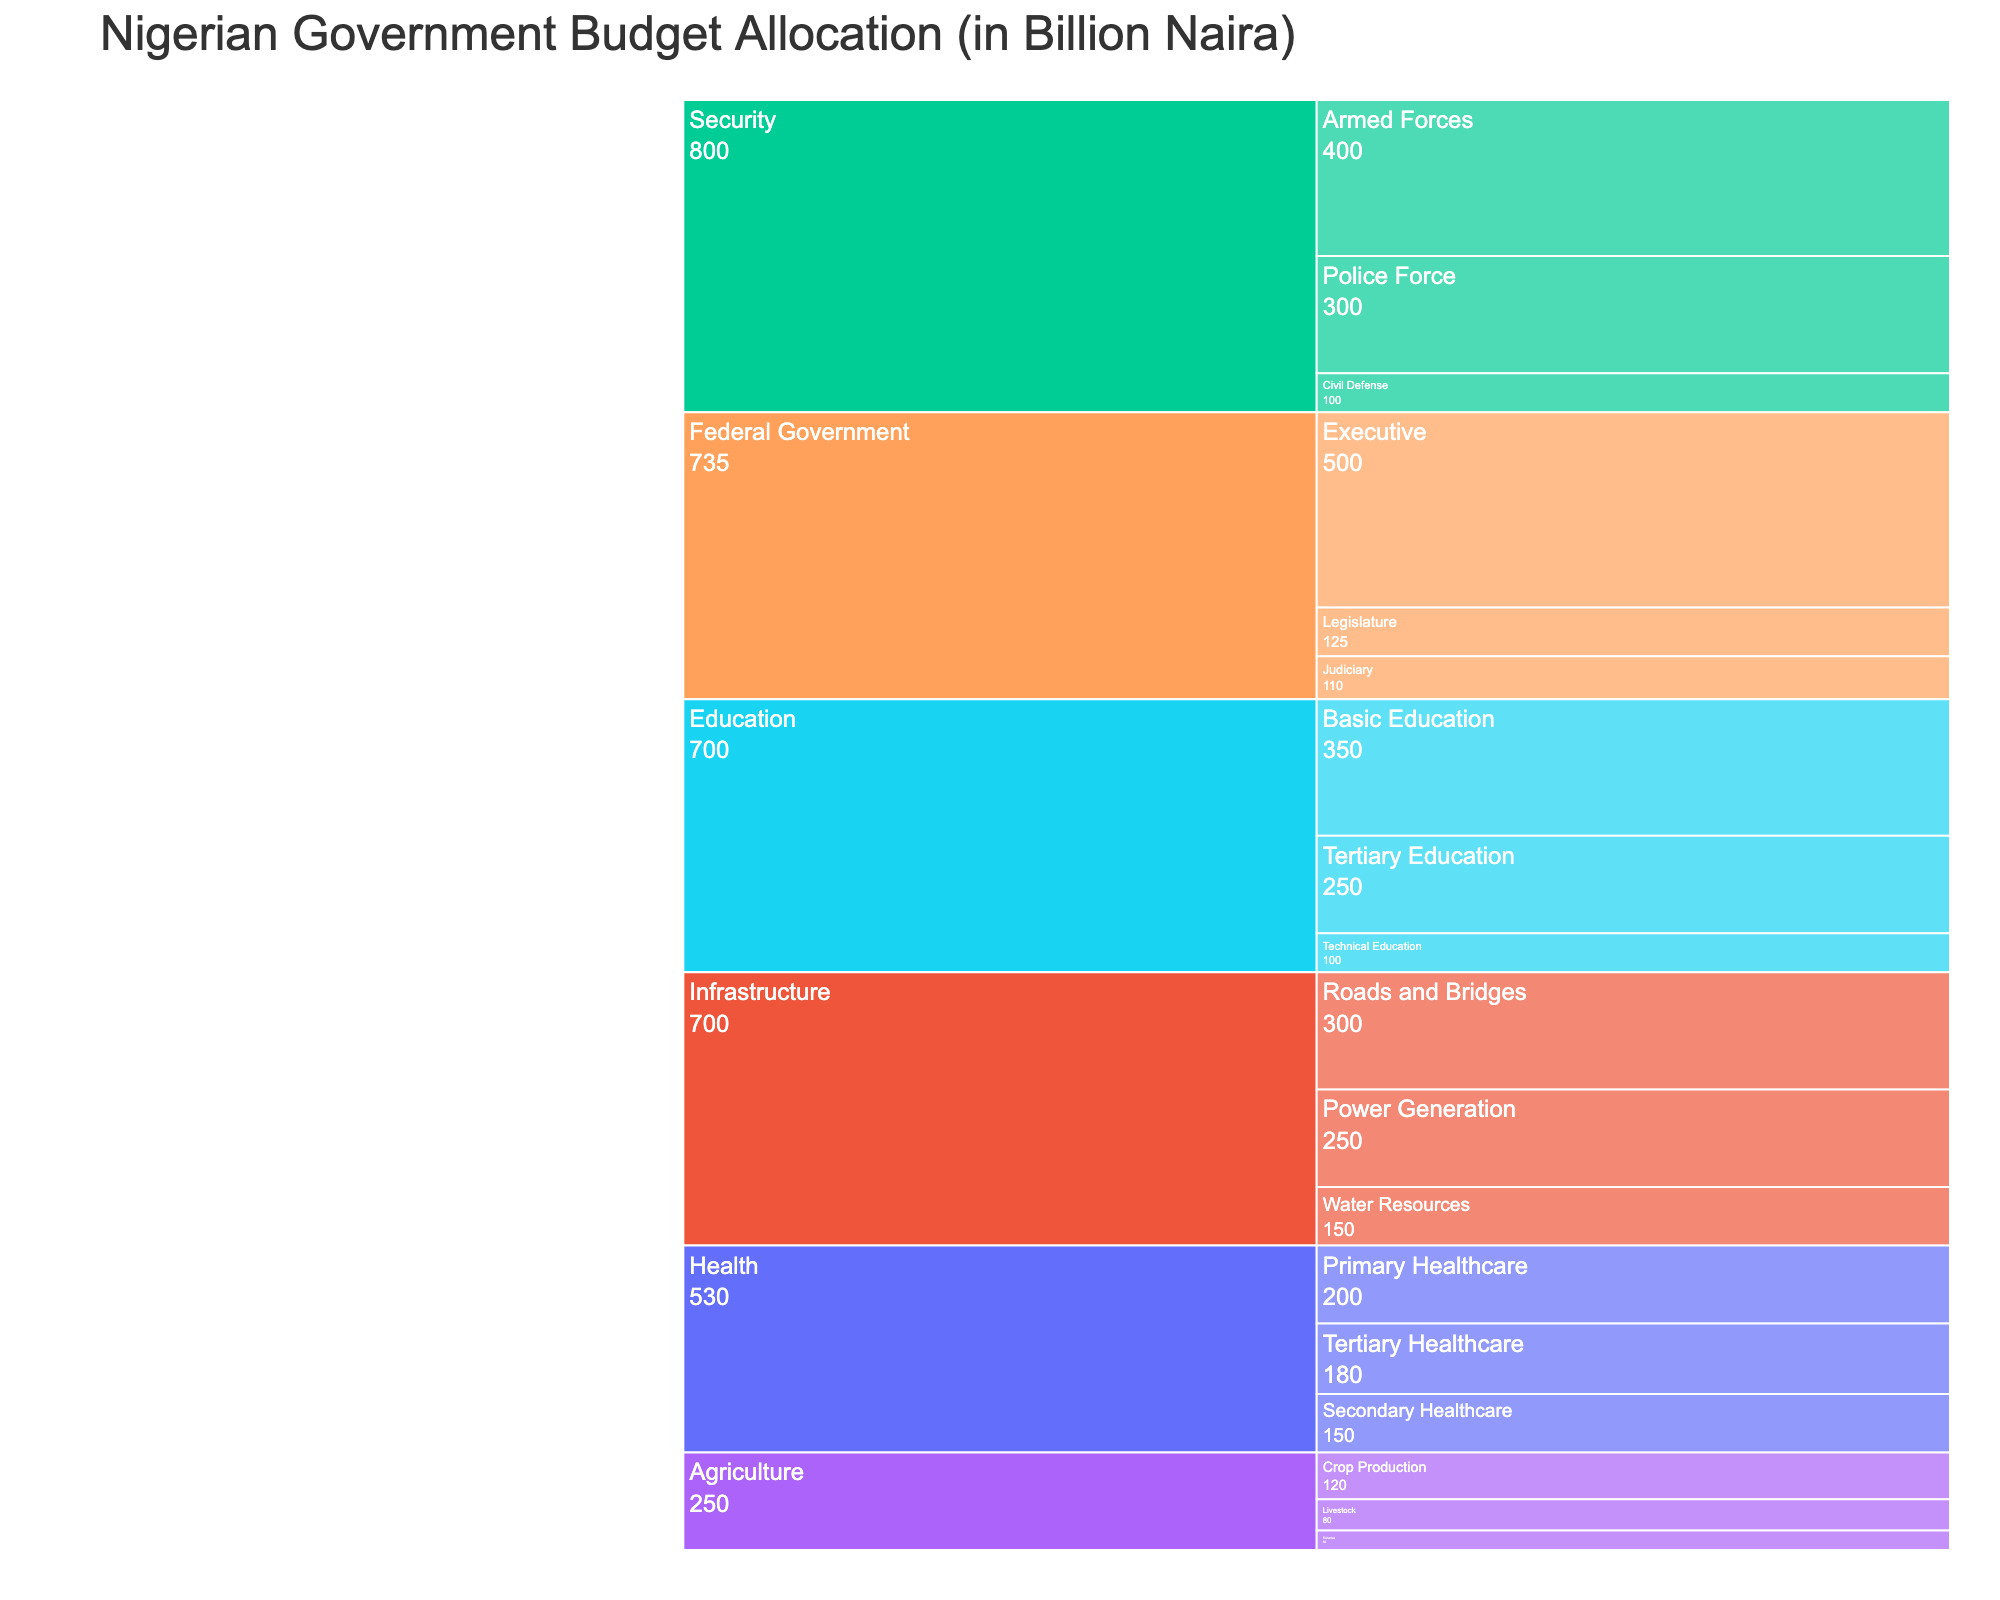What's the title of the chart? The title is located at the top of the chart.
Answer: Nigerian Government Budget Allocation (in Billion Naira) What sub-sector receives the highest allocation in the Security sector? Look at the section for Security. The sub-sector with the highest allocation in Security is the Armed Forces.
Answer: Armed Forces What is the total budget allocation for the Education sector? Add the budget allocations for Basic Education, Tertiary Education, and Technical Education: 350 + 250 + 100 = 700 Billion Naira.
Answer: 700 Billion Naira Which sector has the lowest total allocation, and what is the amount? Compare the total allocations for all main sectors. Sub-sectors under Agriculture add up to 250 Billion Naira, which is the lowest.
Answer: Agriculture, 250 Billion Naira How does the budget allocation for Roads and Bridges compare to Power Generation in the Infrastructure sector? The allocation for Roads and Bridges is 300 Billion Naira, and for Power Generation, it is 250 Billion Naira. Roads and Bridges receive 50 Billion Naira more.
Answer: Roads and Bridges receive 50 Billion Naira more What is the budget allocation for the Executive sub-sector? Look at the Executive sub-sector under the Federal Government sector.
Answer: 500 Billion Naira What is the combined allocation for Primary Healthcare and Secondary Healthcare? Add the budget allocations for Primary Healthcare and Secondary Healthcare: 200 + 150 = 350 Billion Naira.
Answer: 350 Billion Naira Which sub-sector within the Agriculture sector receives the second-highest allocation? Within the Agriculture sector, compare the allocations for each sub-sector. Crop Production is the highest, and Livestock is the second-highest with 80 Billion Naira.
Answer: Livestock What is the difference in allocation between the Judiciary and Legislature sub-sectors under the Federal Government? Subtract the allocation for the Legislature (125) from that of the Judiciary (110): 125 - 110 = 15 Billion Naira.
Answer: 15 Billion Naira Which sub-sector in Health has the highest allocation, and what is the amount? Within the Health sector, compare the sub-sectors. The highest allocation is for Tertiary Healthcare, with 180 Billion Naira.
Answer: Tertiary Healthcare, 180 Billion Naira 